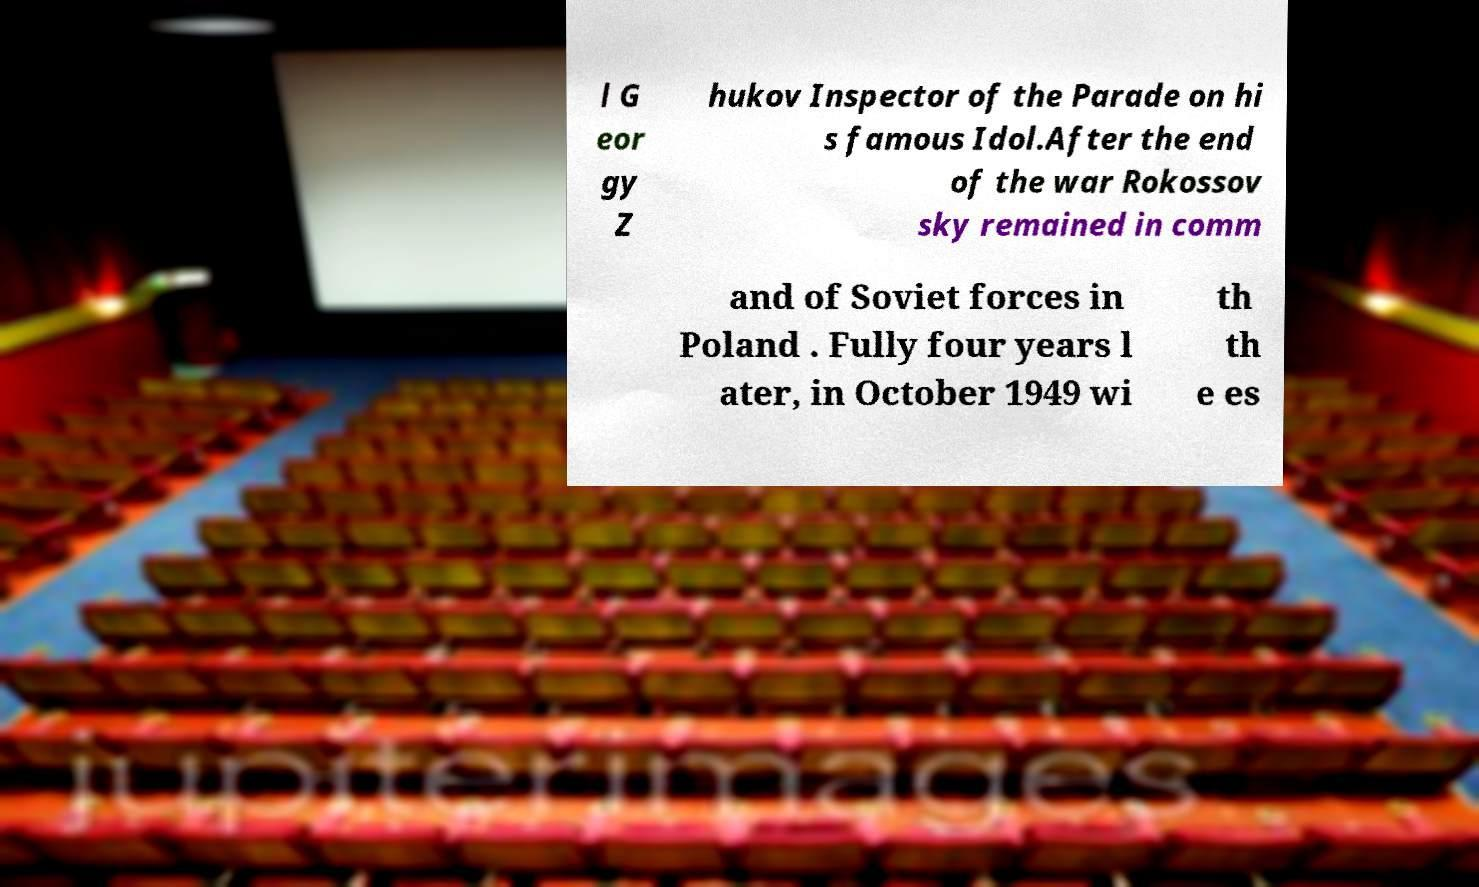For documentation purposes, I need the text within this image transcribed. Could you provide that? l G eor gy Z hukov Inspector of the Parade on hi s famous Idol.After the end of the war Rokossov sky remained in comm and of Soviet forces in Poland . Fully four years l ater, in October 1949 wi th th e es 